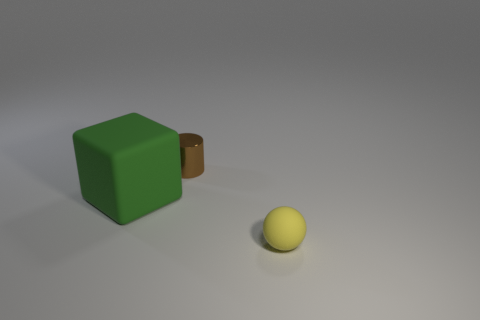Is there anything else that is the same shape as the large green object?
Offer a very short reply. No. Is there a large green rubber block that is to the right of the rubber thing that is on the left side of the yellow object that is in front of the tiny metal cylinder?
Offer a very short reply. No. The matte ball is what color?
Your answer should be very brief. Yellow. There is a rubber object that is the same size as the cylinder; what color is it?
Your answer should be very brief. Yellow. Do the tiny thing on the left side of the tiny rubber thing and the large green rubber thing have the same shape?
Provide a short and direct response. No. The small thing that is on the left side of the thing that is in front of the rubber object behind the yellow rubber ball is what color?
Keep it short and to the point. Brown. Are there any big red balls?
Provide a short and direct response. No. What number of other things are there of the same size as the yellow matte thing?
Offer a terse response. 1. There is a block; is its color the same as the matte thing that is on the right side of the big green matte thing?
Your answer should be compact. No. What number of things are either green balls or objects?
Your answer should be compact. 3. 